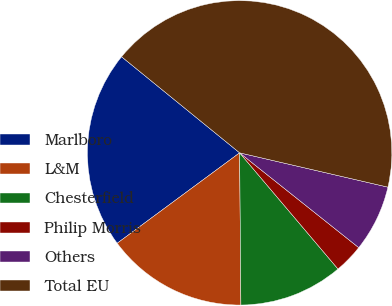Convert chart to OTSL. <chart><loc_0><loc_0><loc_500><loc_500><pie_chart><fcel>Marlboro<fcel>L&M<fcel>Chesterfield<fcel>Philip Morris<fcel>Others<fcel>Total EU<nl><fcel>21.0%<fcel>15.01%<fcel>11.05%<fcel>3.12%<fcel>7.08%<fcel>42.75%<nl></chart> 